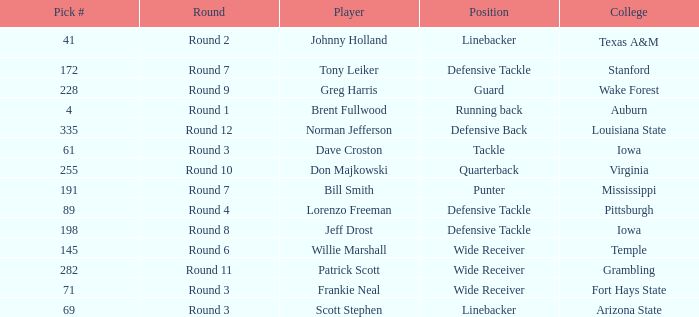What was the pick# for Lorenzo Freeman as defensive tackle? 89.0. 